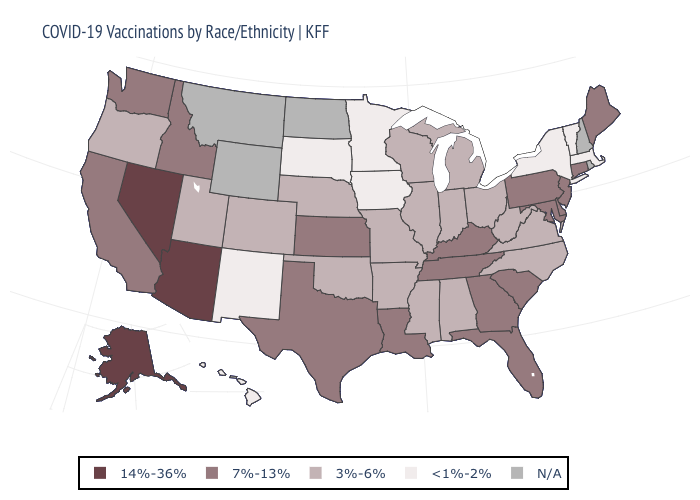Name the states that have a value in the range <1%-2%?
Give a very brief answer. Hawaii, Iowa, Massachusetts, Minnesota, New Mexico, New York, South Dakota, Vermont. What is the value of Hawaii?
Keep it brief. <1%-2%. Does Vermont have the lowest value in the USA?
Short answer required. Yes. What is the value of Maine?
Quick response, please. 7%-13%. What is the value of South Carolina?
Keep it brief. 7%-13%. How many symbols are there in the legend?
Be succinct. 5. Name the states that have a value in the range 3%-6%?
Be succinct. Alabama, Arkansas, Colorado, Illinois, Indiana, Michigan, Mississippi, Missouri, Nebraska, North Carolina, Ohio, Oklahoma, Oregon, Utah, Virginia, West Virginia, Wisconsin. Does the first symbol in the legend represent the smallest category?
Be succinct. No. Among the states that border Alabama , does Tennessee have the lowest value?
Keep it brief. No. What is the value of Louisiana?
Concise answer only. 7%-13%. Name the states that have a value in the range 3%-6%?
Write a very short answer. Alabama, Arkansas, Colorado, Illinois, Indiana, Michigan, Mississippi, Missouri, Nebraska, North Carolina, Ohio, Oklahoma, Oregon, Utah, Virginia, West Virginia, Wisconsin. Which states have the lowest value in the USA?
Quick response, please. Hawaii, Iowa, Massachusetts, Minnesota, New Mexico, New York, South Dakota, Vermont. What is the highest value in states that border Oklahoma?
Quick response, please. 7%-13%. Name the states that have a value in the range 3%-6%?
Give a very brief answer. Alabama, Arkansas, Colorado, Illinois, Indiana, Michigan, Mississippi, Missouri, Nebraska, North Carolina, Ohio, Oklahoma, Oregon, Utah, Virginia, West Virginia, Wisconsin. What is the value of Missouri?
Keep it brief. 3%-6%. 